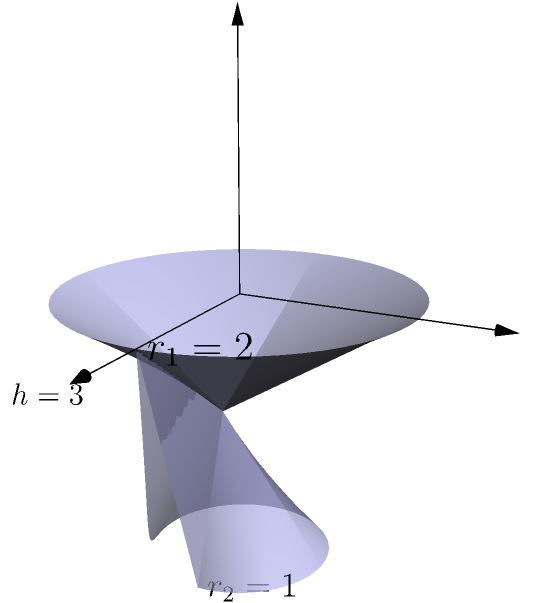As an aspiring entrepreneur, you're designing a unique product container. The container is shaped like a truncated cylinder, as shown in the diagram. The top radius ($r_1$) is 2 units, the bottom radius ($r_2$) is 1 unit, and the height ($h$) is 3 units. Calculate the volume of this container to determine its capacity. Round your answer to two decimal places. To find the volume of a truncated cylinder, we can use the following formula:

$$V = \frac{1}{3}\pi h(r_1^2 + r_2^2 + r_1r_2)$$

Where:
$V$ = volume
$h$ = height
$r_1$ = radius of the top base
$r_2$ = radius of the bottom base

Let's substitute the given values:
$h = 3$
$r_1 = 2$
$r_2 = 1$

Now, let's calculate step by step:

1) $V = \frac{1}{3}\pi \cdot 3(2^2 + 1^2 + 2 \cdot 1)$

2) $V = \pi(4 + 1 + 2)$

3) $V = 7\pi$

4) $V \approx 21.9911$

Rounding to two decimal places:

5) $V \approx 21.99$ cubic units
Answer: 21.99 cubic units 